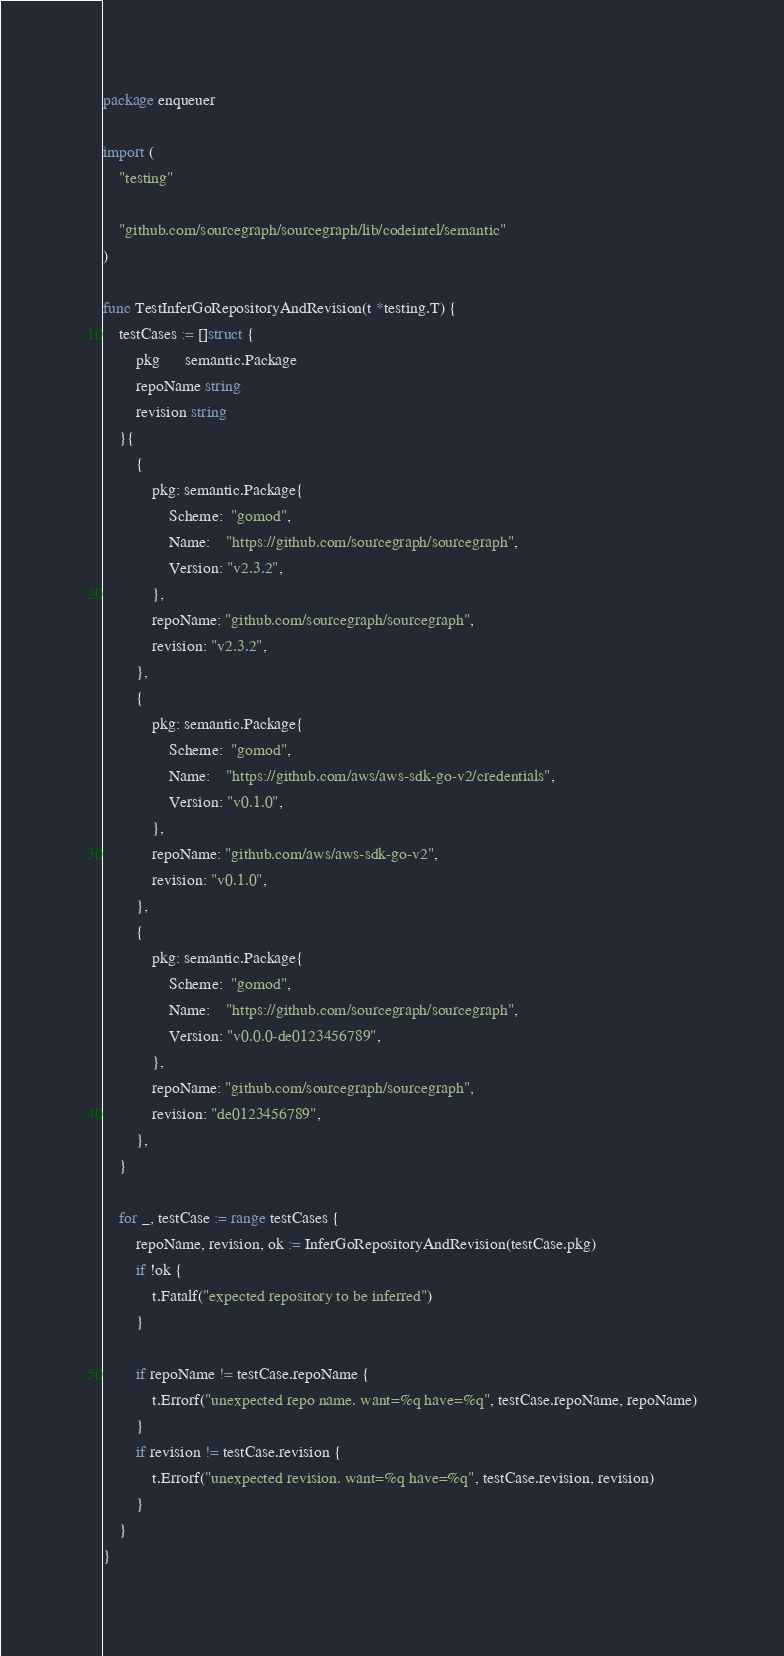Convert code to text. <code><loc_0><loc_0><loc_500><loc_500><_Go_>package enqueuer

import (
	"testing"

	"github.com/sourcegraph/sourcegraph/lib/codeintel/semantic"
)

func TestInferGoRepositoryAndRevision(t *testing.T) {
	testCases := []struct {
		pkg      semantic.Package
		repoName string
		revision string
	}{
		{
			pkg: semantic.Package{
				Scheme:  "gomod",
				Name:    "https://github.com/sourcegraph/sourcegraph",
				Version: "v2.3.2",
			},
			repoName: "github.com/sourcegraph/sourcegraph",
			revision: "v2.3.2",
		},
		{
			pkg: semantic.Package{
				Scheme:  "gomod",
				Name:    "https://github.com/aws/aws-sdk-go-v2/credentials",
				Version: "v0.1.0",
			},
			repoName: "github.com/aws/aws-sdk-go-v2",
			revision: "v0.1.0",
		},
		{
			pkg: semantic.Package{
				Scheme:  "gomod",
				Name:    "https://github.com/sourcegraph/sourcegraph",
				Version: "v0.0.0-de0123456789",
			},
			repoName: "github.com/sourcegraph/sourcegraph",
			revision: "de0123456789",
		},
	}

	for _, testCase := range testCases {
		repoName, revision, ok := InferGoRepositoryAndRevision(testCase.pkg)
		if !ok {
			t.Fatalf("expected repository to be inferred")
		}

		if repoName != testCase.repoName {
			t.Errorf("unexpected repo name. want=%q have=%q", testCase.repoName, repoName)
		}
		if revision != testCase.revision {
			t.Errorf("unexpected revision. want=%q have=%q", testCase.revision, revision)
		}
	}
}
</code> 